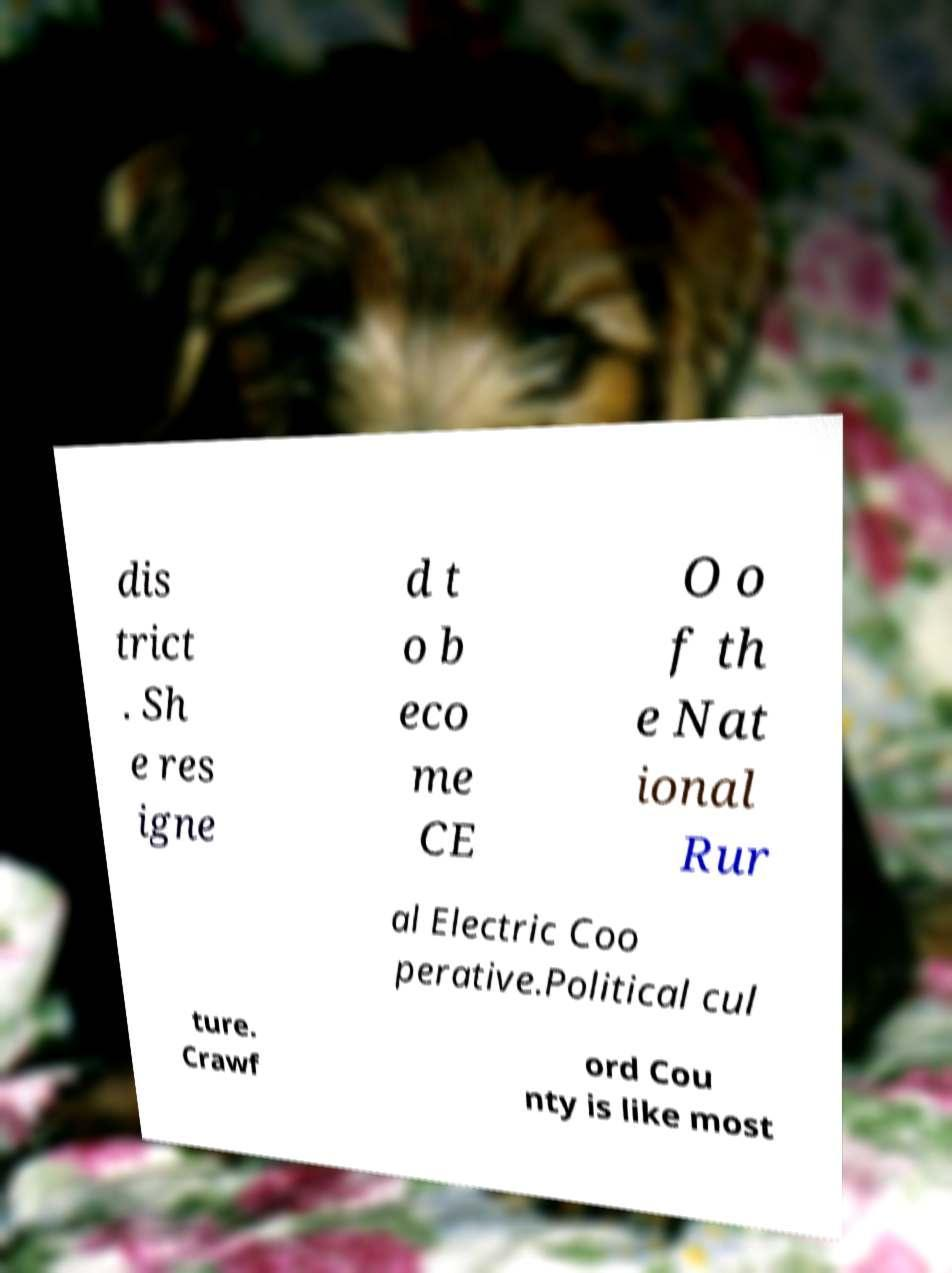I need the written content from this picture converted into text. Can you do that? dis trict . Sh e res igne d t o b eco me CE O o f th e Nat ional Rur al Electric Coo perative.Political cul ture. Crawf ord Cou nty is like most 